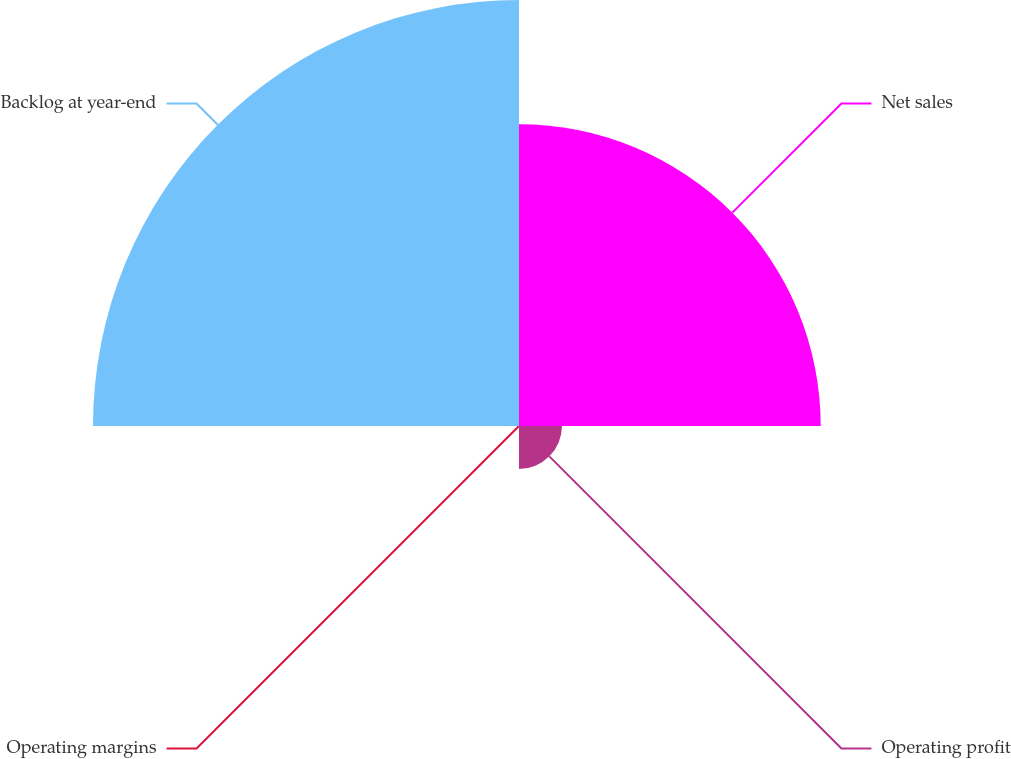Convert chart. <chart><loc_0><loc_0><loc_500><loc_500><pie_chart><fcel>Net sales<fcel>Operating profit<fcel>Operating margins<fcel>Backlog at year-end<nl><fcel>39.13%<fcel>5.57%<fcel>0.05%<fcel>55.25%<nl></chart> 